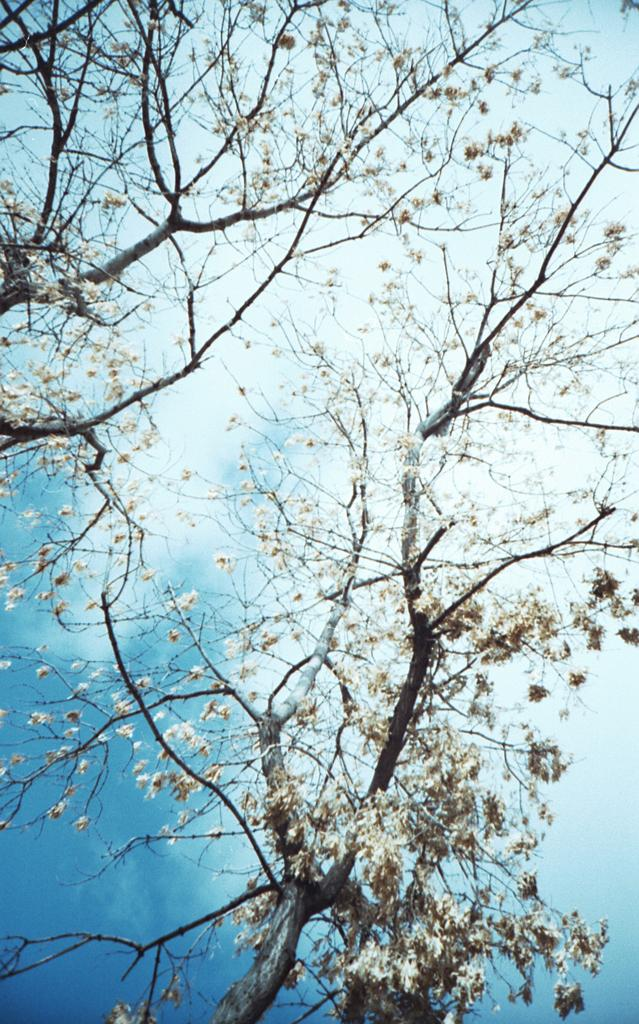What type of vegetation can be seen in the image? There are trees in the image. What part of the natural environment is visible in the image? The sky is visible in the image. What can be observed in the sky? Clouds are present in the sky. What type of pleasure can be seen in the image? There is no indication of pleasure in the image; it features trees and a sky with clouds. 